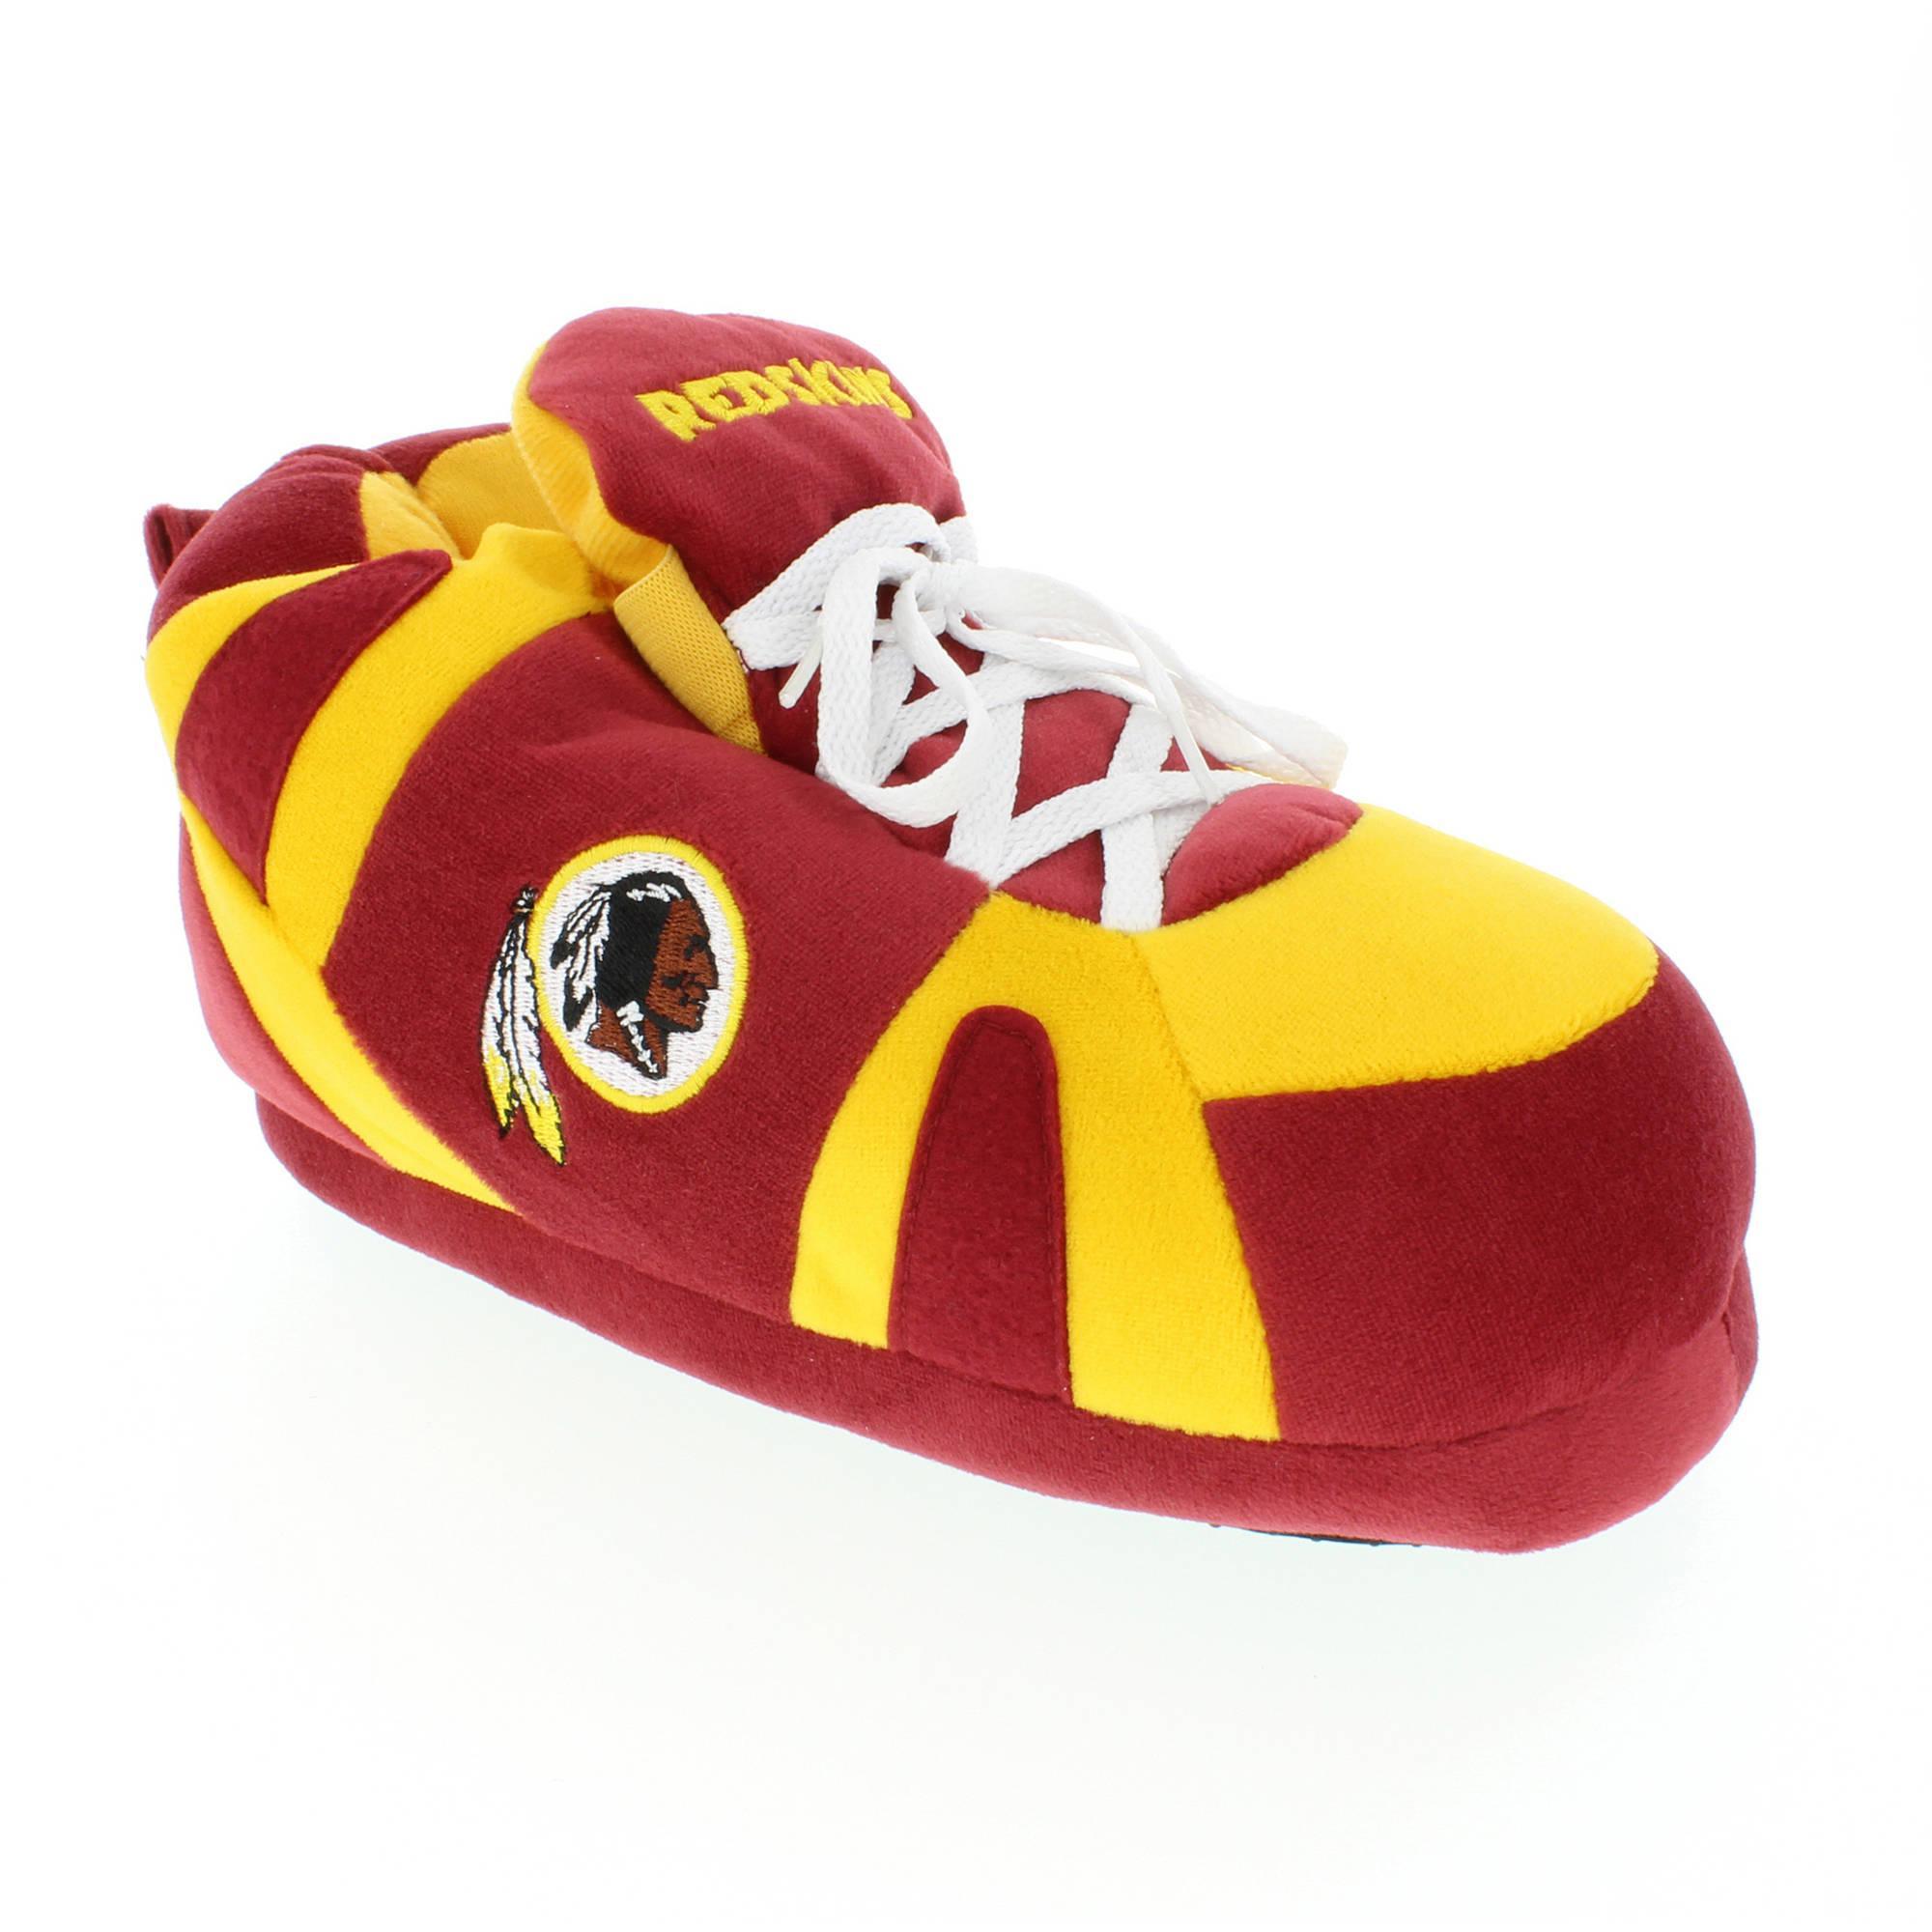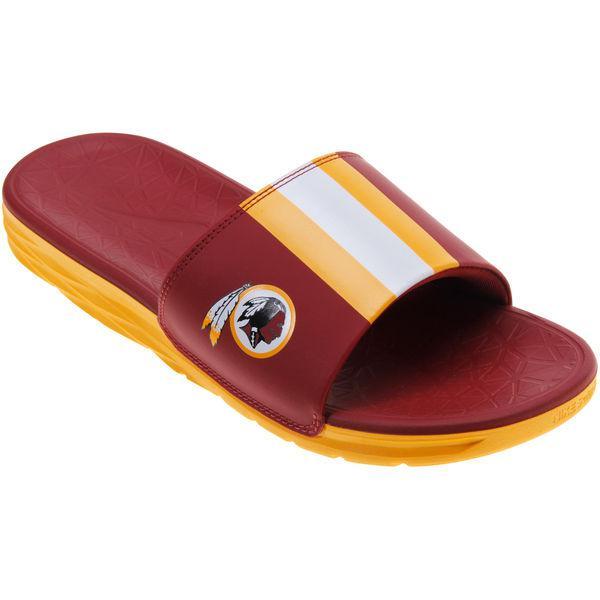The first image is the image on the left, the second image is the image on the right. Assess this claim about the two images: "A tan pair of moccasins in one image has a sports logo on each one that is the same logo seen on a red and yellow slipper in the other image.". Correct or not? Answer yes or no. No. The first image is the image on the left, the second image is the image on the right. Examine the images to the left and right. Is the description "Each footwear item features a sillhouette of an Indian warrior, and the left image contains one yellow and burgundy slipper, while the right image contains a pair of moccasins." accurate? Answer yes or no. No. 